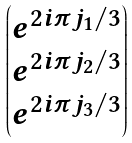<formula> <loc_0><loc_0><loc_500><loc_500>\begin{pmatrix} e ^ { 2 i \pi j _ { 1 } / 3 } \\ e ^ { 2 i \pi j _ { 2 } / 3 } \\ e ^ { 2 i \pi j _ { 3 } / 3 } \end{pmatrix}</formula> 